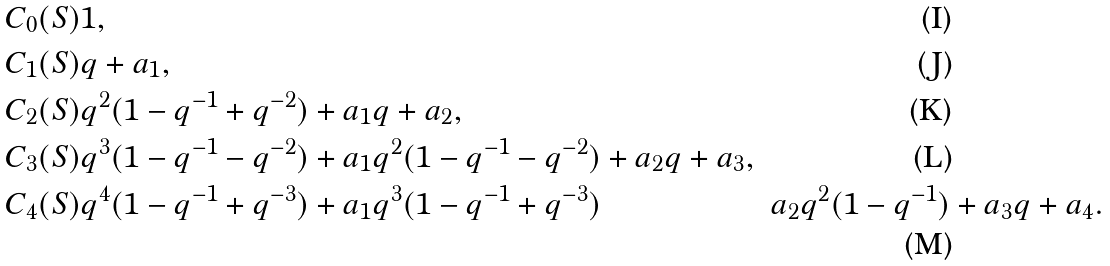Convert formula to latex. <formula><loc_0><loc_0><loc_500><loc_500>C _ { 0 } ( S ) & 1 , \\ C _ { 1 } ( S ) & q + a _ { 1 } , \\ C _ { 2 } ( S ) & q ^ { 2 } ( 1 - q ^ { - 1 } + q ^ { - 2 } ) + a _ { 1 } q + a _ { 2 } , \\ C _ { 3 } ( S ) & q ^ { 3 } ( 1 - q ^ { - 1 } - q ^ { - 2 } ) + a _ { 1 } q ^ { 2 } ( 1 - q ^ { - 1 } - q ^ { - 2 } ) + a _ { 2 } q + a _ { 3 } , \\ C _ { 4 } ( S ) & q ^ { 4 } ( 1 - q ^ { - 1 } + q ^ { - 3 } ) + a _ { 1 } q ^ { 3 } ( 1 - q ^ { - 1 } + q ^ { - 3 } ) & a _ { 2 } q ^ { 2 } ( 1 - q ^ { - 1 } ) + a _ { 3 } q + a _ { 4 } .</formula> 